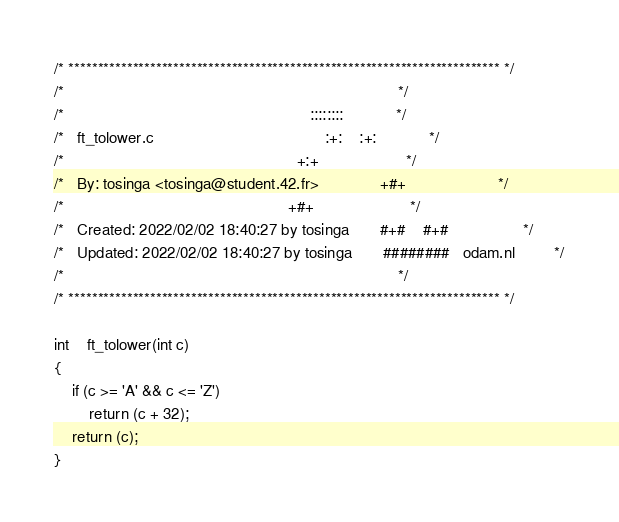<code> <loc_0><loc_0><loc_500><loc_500><_C_>/* ************************************************************************** */
/*                                                                            */
/*                                                        ::::::::            */
/*   ft_tolower.c                                       :+:    :+:            */
/*                                                     +:+                    */
/*   By: tosinga <tosinga@student.42.fr>              +#+                     */
/*                                                   +#+                      */
/*   Created: 2022/02/02 18:40:27 by tosinga       #+#    #+#                 */
/*   Updated: 2022/02/02 18:40:27 by tosinga       ########   odam.nl         */
/*                                                                            */
/* ************************************************************************** */

int	ft_tolower(int c)
{
	if (c >= 'A' && c <= 'Z')
		return (c + 32);
	return (c);
}
</code> 